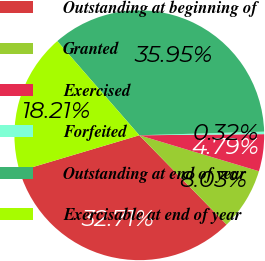<chart> <loc_0><loc_0><loc_500><loc_500><pie_chart><fcel>Outstanding at beginning of<fcel>Granted<fcel>Exercised<fcel>Forfeited<fcel>Outstanding at end of year<fcel>Exercisable at end of year<nl><fcel>32.71%<fcel>8.03%<fcel>4.79%<fcel>0.32%<fcel>35.95%<fcel>18.21%<nl></chart> 